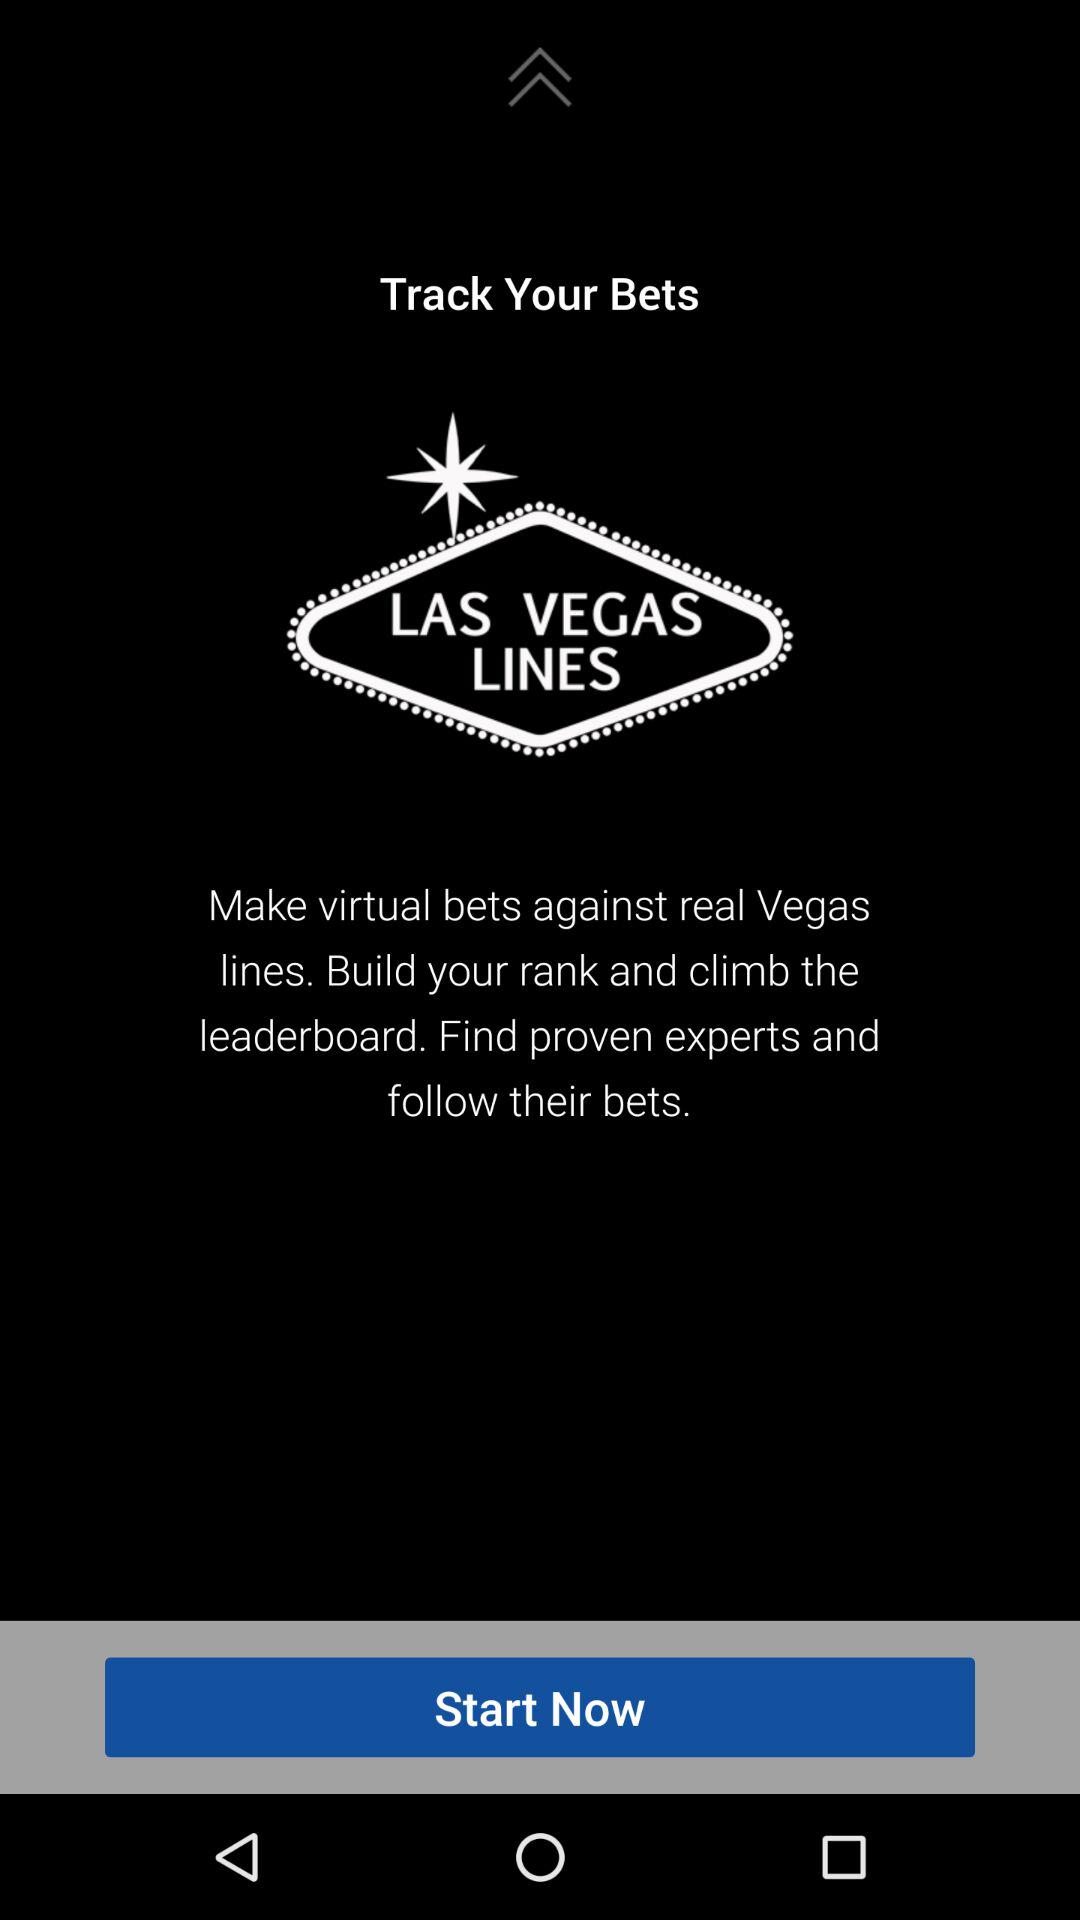What is the app name?
When the provided information is insufficient, respond with <no answer>. <no answer> 